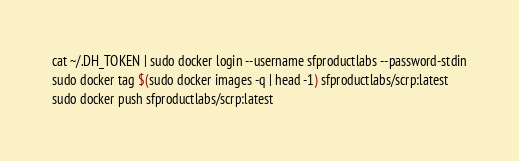Convert code to text. <code><loc_0><loc_0><loc_500><loc_500><_Bash_>cat ~/.DH_TOKEN | sudo docker login --username sfproductlabs --password-stdin
sudo docker tag $(sudo docker images -q | head -1) sfproductlabs/scrp:latest
sudo docker push sfproductlabs/scrp:latest</code> 